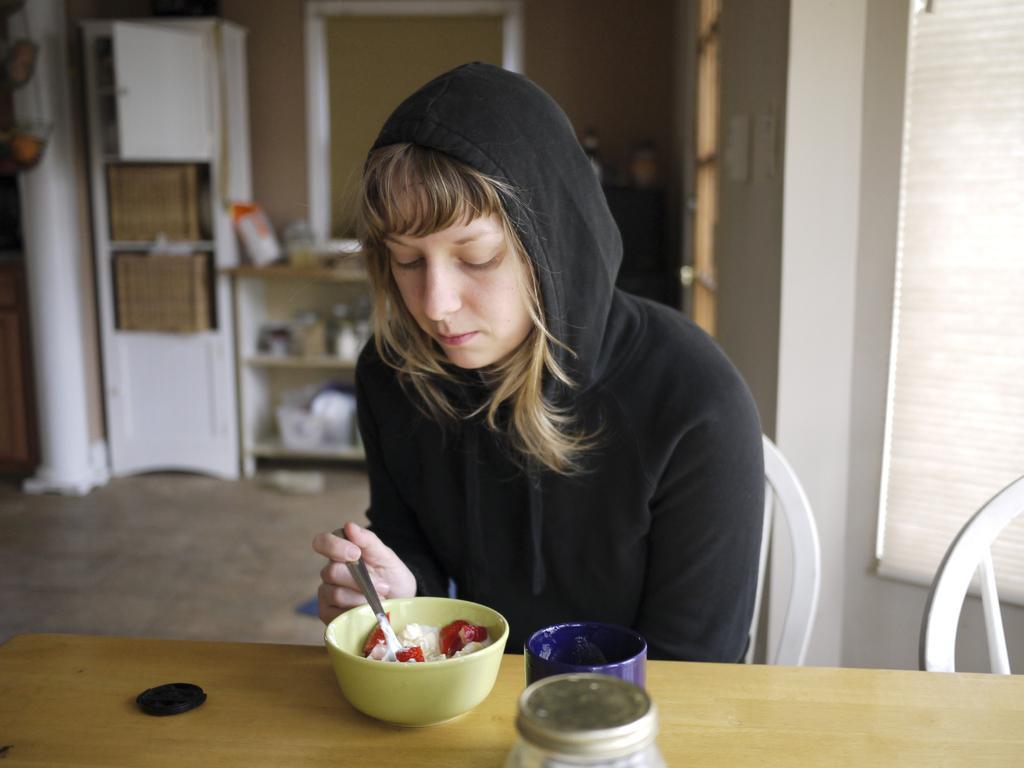Please provide a concise description of this image. A woman is sitting on the chair holding a spoon wearing sweater. 